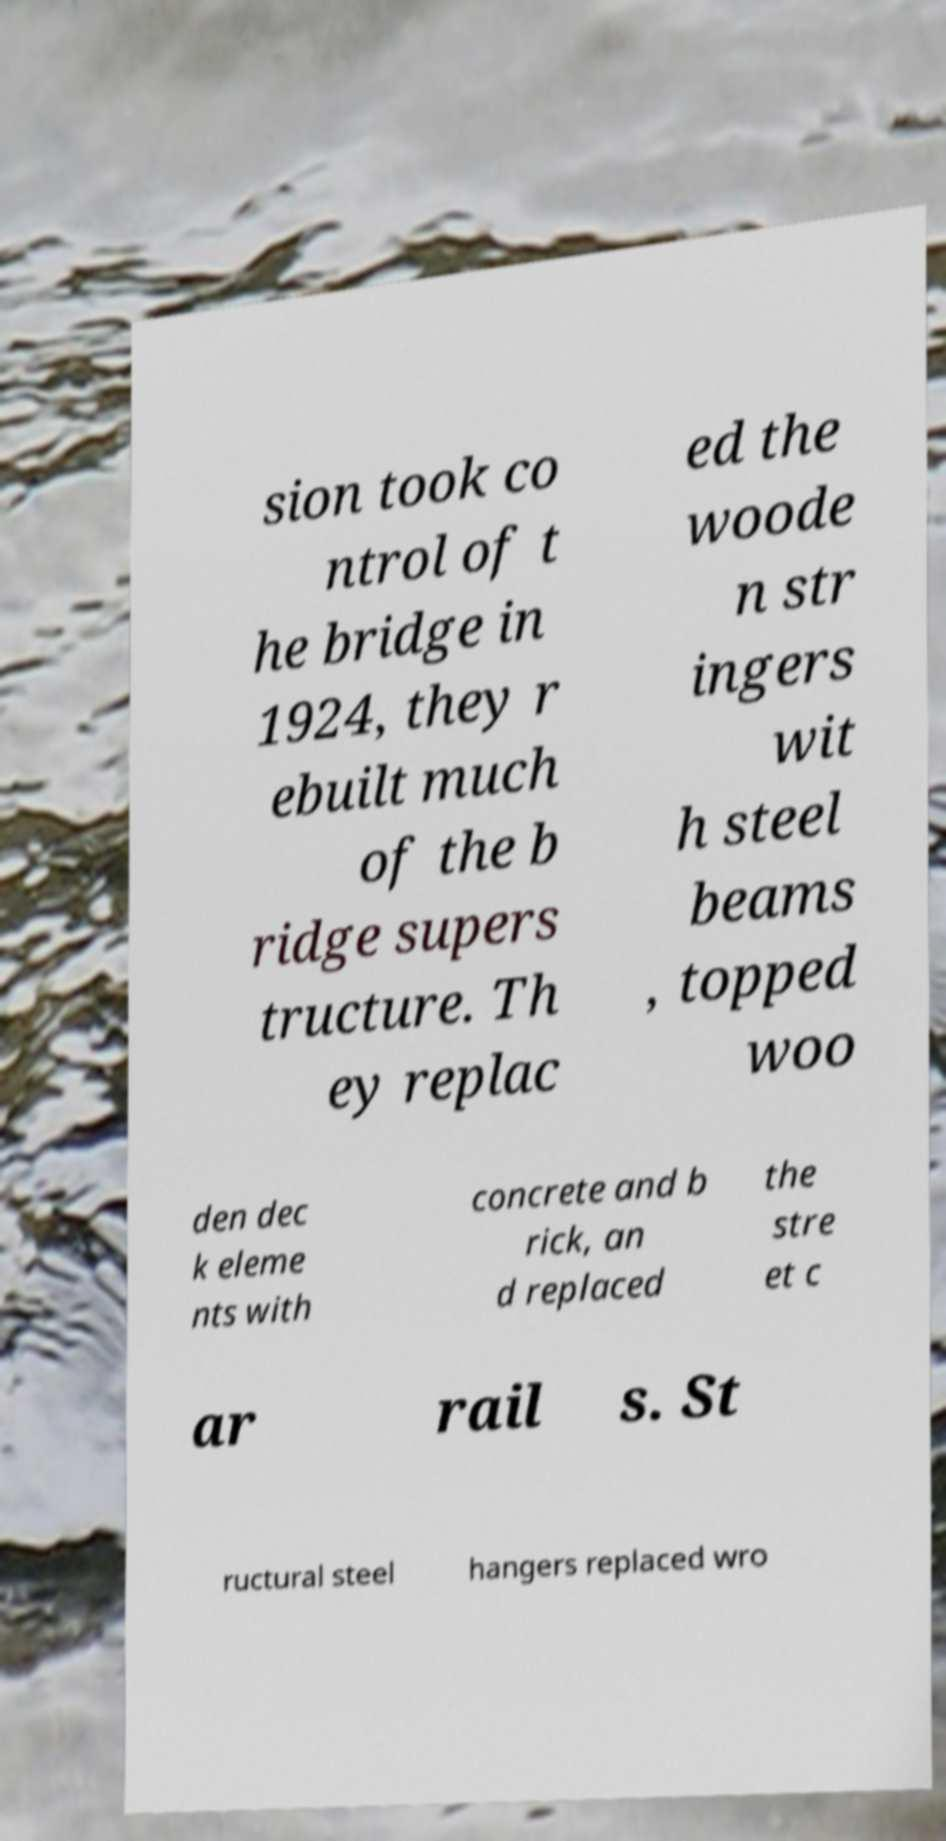For documentation purposes, I need the text within this image transcribed. Could you provide that? sion took co ntrol of t he bridge in 1924, they r ebuilt much of the b ridge supers tructure. Th ey replac ed the woode n str ingers wit h steel beams , topped woo den dec k eleme nts with concrete and b rick, an d replaced the stre et c ar rail s. St ructural steel hangers replaced wro 